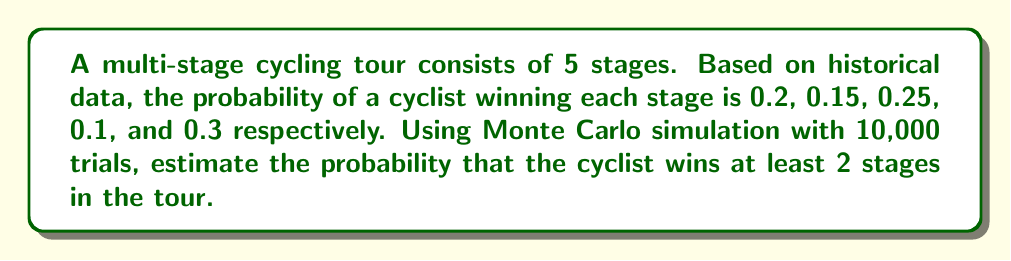Can you answer this question? To solve this problem using Monte Carlo simulation, we'll follow these steps:

1) Set up the simulation:
   - Number of stages: 5
   - Probabilities of winning each stage: $p = [0.2, 0.15, 0.25, 0.1, 0.3]$
   - Number of trials: 10,000

2) For each trial:
   a) Generate a random number between 0 and 1 for each stage
   b) If the random number is less than the probability of winning that stage, count it as a win
   c) Sum the total number of wins for the trial

3) Count the number of trials where the cyclist wins at least 2 stages

4) Calculate the estimated probability

Here's a Python implementation of the simulation:

```python
import numpy as np

np.random.seed(42)  # for reproducibility
stages = 5
probabilities = [0.2, 0.15, 0.25, 0.1, 0.3]
trials = 10000

wins = np.random.random((trials, stages)) < probabilities
at_least_two_wins = np.sum(wins, axis=1) >= 2
probability = np.mean(at_least_two_wins)
```

5) Interpret the results:
   The estimated probability is the number of favorable outcomes (trials with at least 2 wins) divided by the total number of trials.

6) Calculate the theoretical probability for comparison:
   We can use the binomial distribution to calculate the exact probability:

   $$P(\text{at least 2 wins}) = 1 - P(0 \text{ wins}) - P(1 \text{ win})$$

   $$= 1 - \prod_{i=1}^5 (1-p_i) - \sum_{i=1}^5 p_i \prod_{j \neq i} (1-p_j)$$

   This calculation serves as a check for our Monte Carlo simulation.

The Monte Carlo simulation provides an estimate that converges to the true probability as the number of trials increases.
Answer: $\approx 0.3866$ (Monte Carlo estimate, actual value may vary slightly due to randomness) 